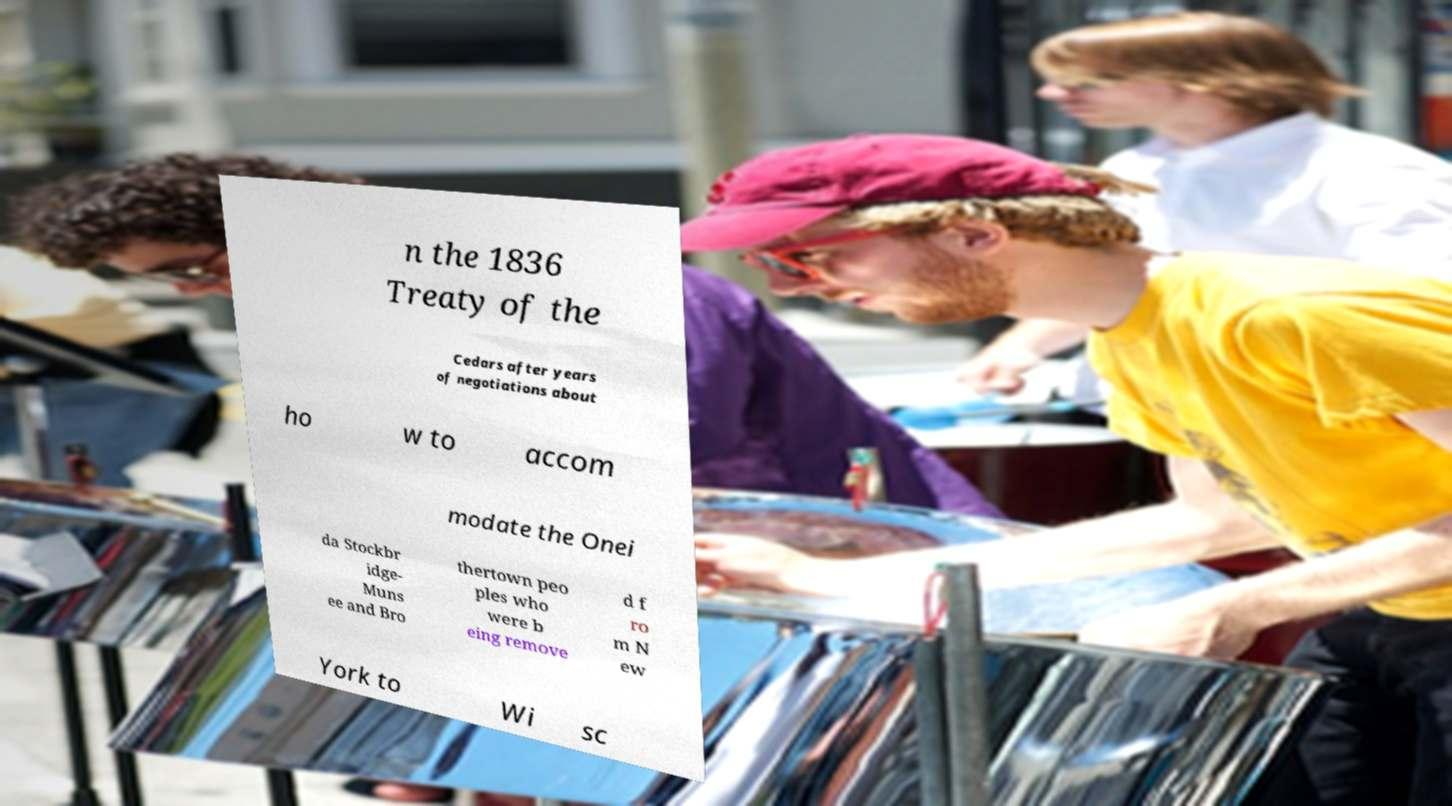For documentation purposes, I need the text within this image transcribed. Could you provide that? n the 1836 Treaty of the Cedars after years of negotiations about ho w to accom modate the Onei da Stockbr idge- Muns ee and Bro thertown peo ples who were b eing remove d f ro m N ew York to Wi sc 